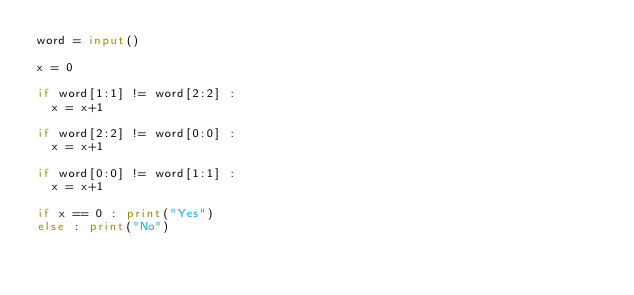<code> <loc_0><loc_0><loc_500><loc_500><_Python_>word = input()

x = 0

if word[1:1] != word[2:2] :
  x = x+1
  
if word[2:2] != word[0:0] :
  x = x+1
  
if word[0:0] != word[1:1] :
  x = x+1
  
if x == 0 : print("Yes")
else : print("No")</code> 